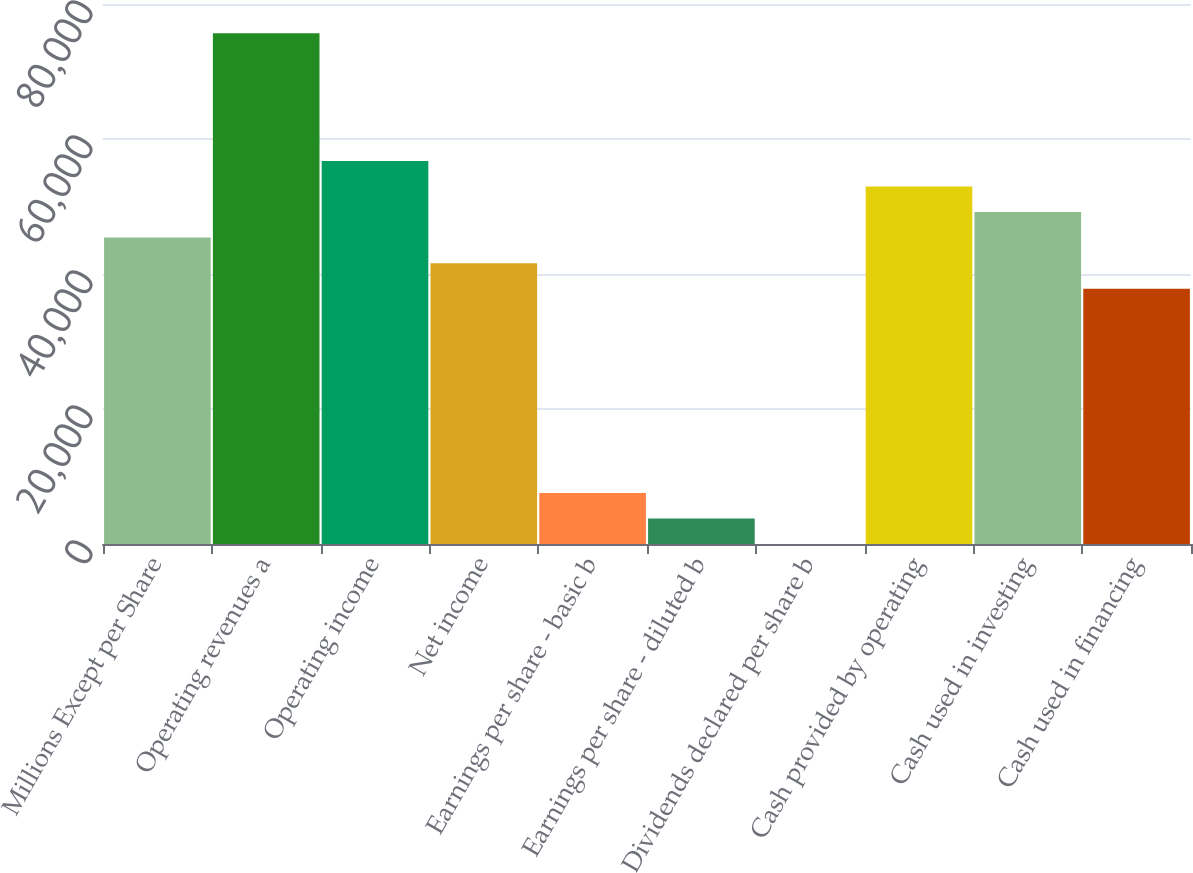Convert chart to OTSL. <chart><loc_0><loc_0><loc_500><loc_500><bar_chart><fcel>Millions Except per Share<fcel>Operating revenues a<fcel>Operating income<fcel>Net income<fcel>Earnings per share - basic b<fcel>Earnings per share - diluted b<fcel>Dividends declared per share b<fcel>Cash provided by operating<fcel>Cash used in investing<fcel>Cash used in financing<nl><fcel>45389.9<fcel>75649.3<fcel>56737.2<fcel>41607.5<fcel>7565.6<fcel>3783.17<fcel>0.74<fcel>52954.8<fcel>49172.3<fcel>37825<nl></chart> 